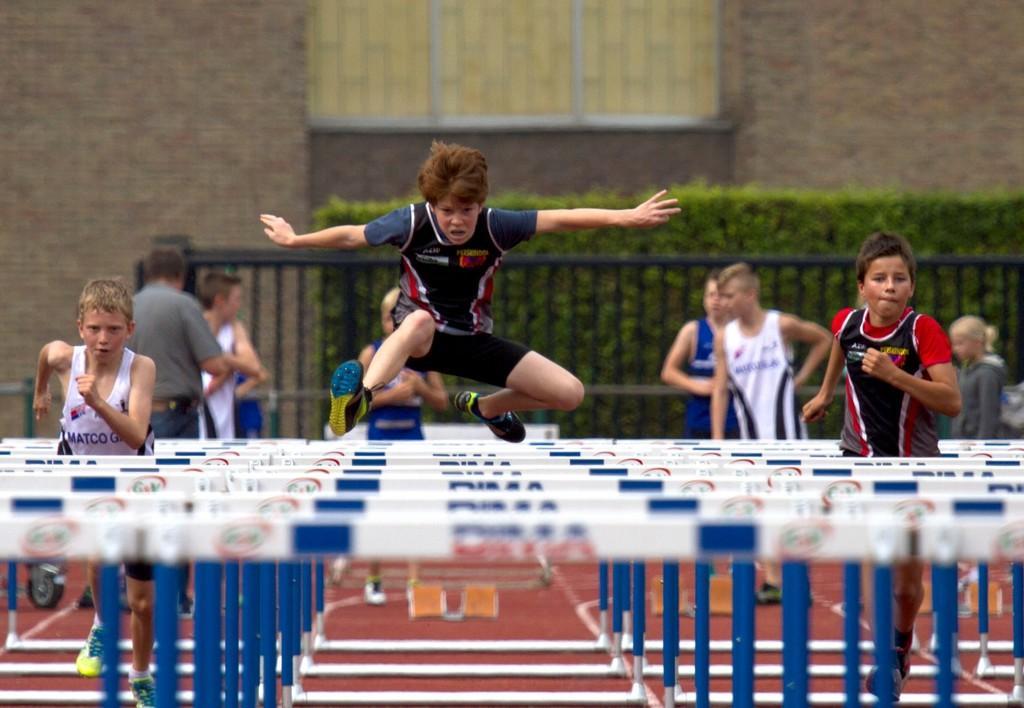How would you summarize this image in a sentence or two? In the center of the image we can see two kids are running and one kid is jumping. And we can see the hurdles. In the background there is a brick wall, window, railing, planter and a few people. 